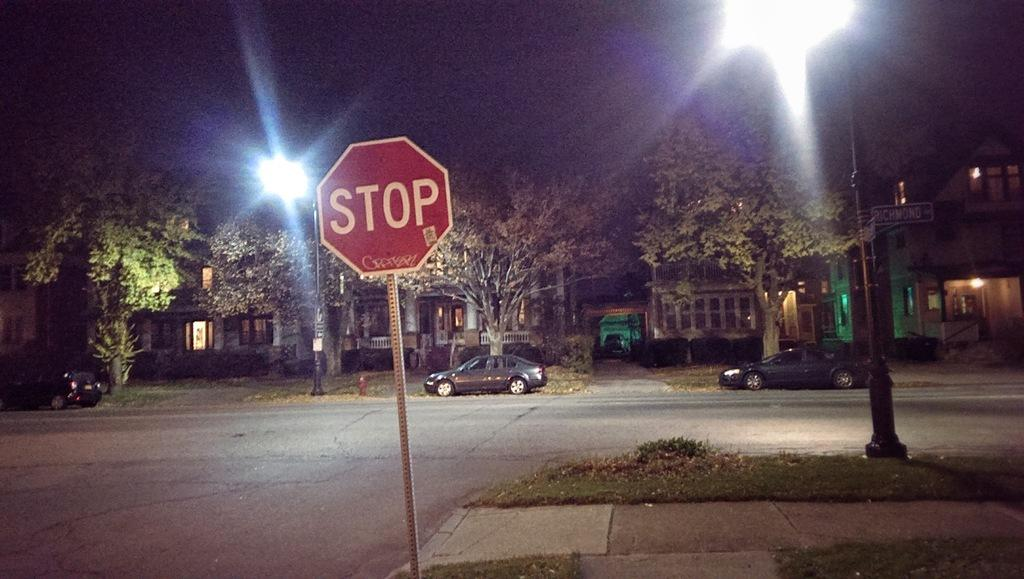<image>
Provide a brief description of the given image. A stop sign in a neighborhood with graffiti on it. 